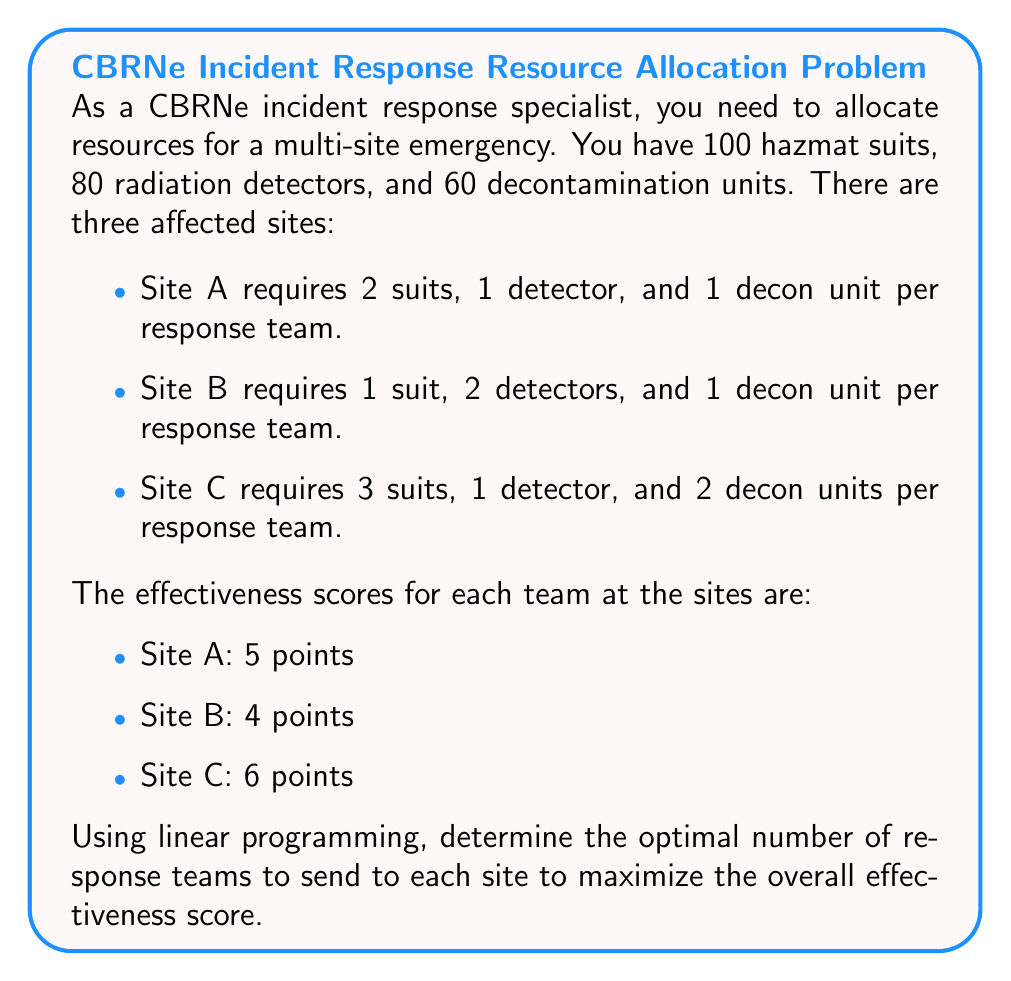Solve this math problem. To solve this problem using linear programming, we need to follow these steps:

1. Define variables:
Let $x$, $y$, and $z$ be the number of teams sent to Sites A, B, and C respectively.

2. Set up the objective function:
Maximize $5x + 4y + 6z$

3. Define constraints:
Resource constraints:
Hazmat suits: $2x + y + 3z \leq 100$
Radiation detectors: $x + 2y + z \leq 80$
Decontamination units: $x + y + 2z \leq 60$

Non-negativity constraints:
$x \geq 0$, $y \geq 0$, $z \geq 0$

4. Solve the linear programming problem:
We can solve this using the simplex method or a linear programming solver. The optimal solution is:

$x = 20$ (teams for Site A)
$y = 30$ (teams for Site B)
$z = 10$ (teams for Site C)

5. Verify the solution:
Resource usage:
Hazmat suits: $2(20) + 1(30) + 3(10) = 100$
Radiation detectors: $1(20) + 2(30) + 1(10) = 80$
Decontamination units: $1(20) + 1(30) + 2(10) = 60$

All constraints are satisfied.

6. Calculate the maximum effectiveness score:
Maximum score = $5(20) + 4(30) + 6(10) = 280$
Answer: The optimal allocation is 20 teams to Site A, 30 teams to Site B, and 10 teams to Site C, resulting in a maximum effectiveness score of 280 points. 